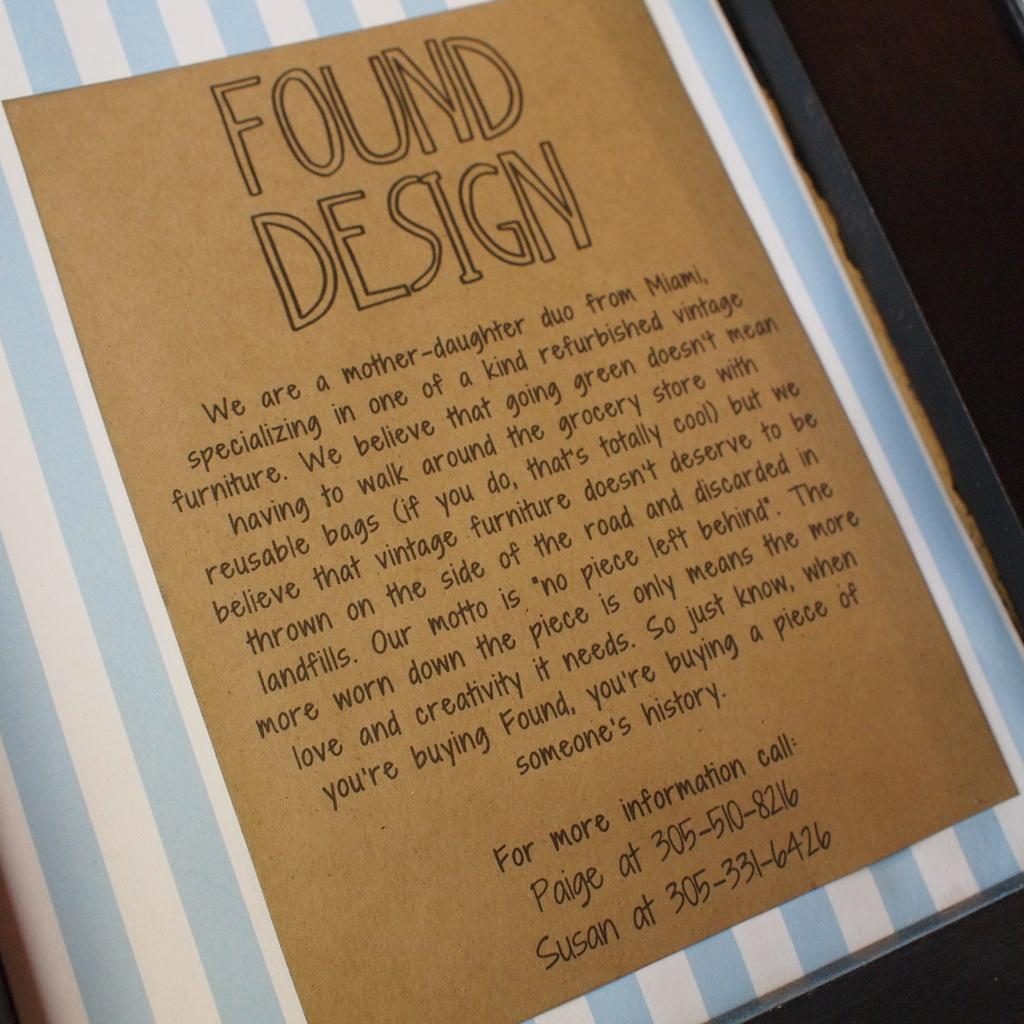<image>
Render a clear and concise summary of the photo. An advertisement for Found Design, which specializes in refurbished vintage furniture, is shown. 